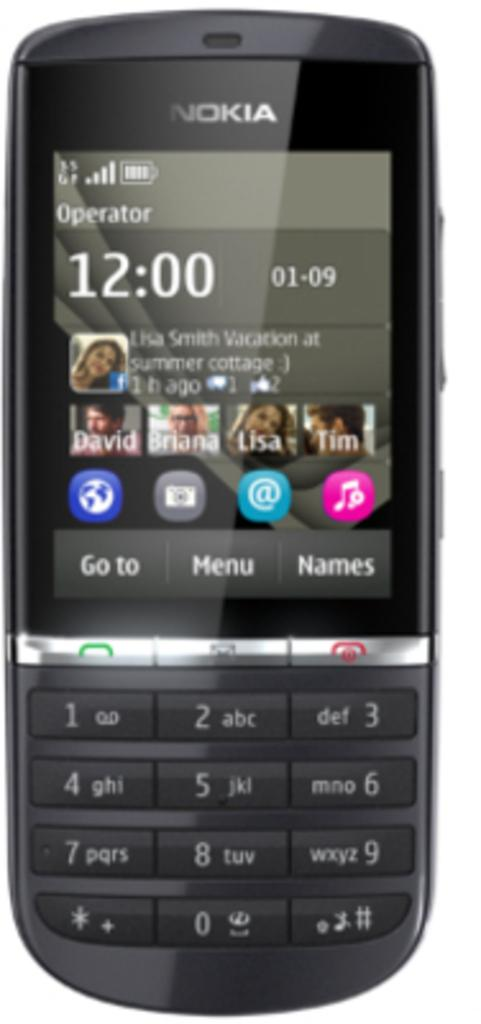<image>
Provide a brief description of the given image. The Nokia phone is smaller than most of today's iphones. 